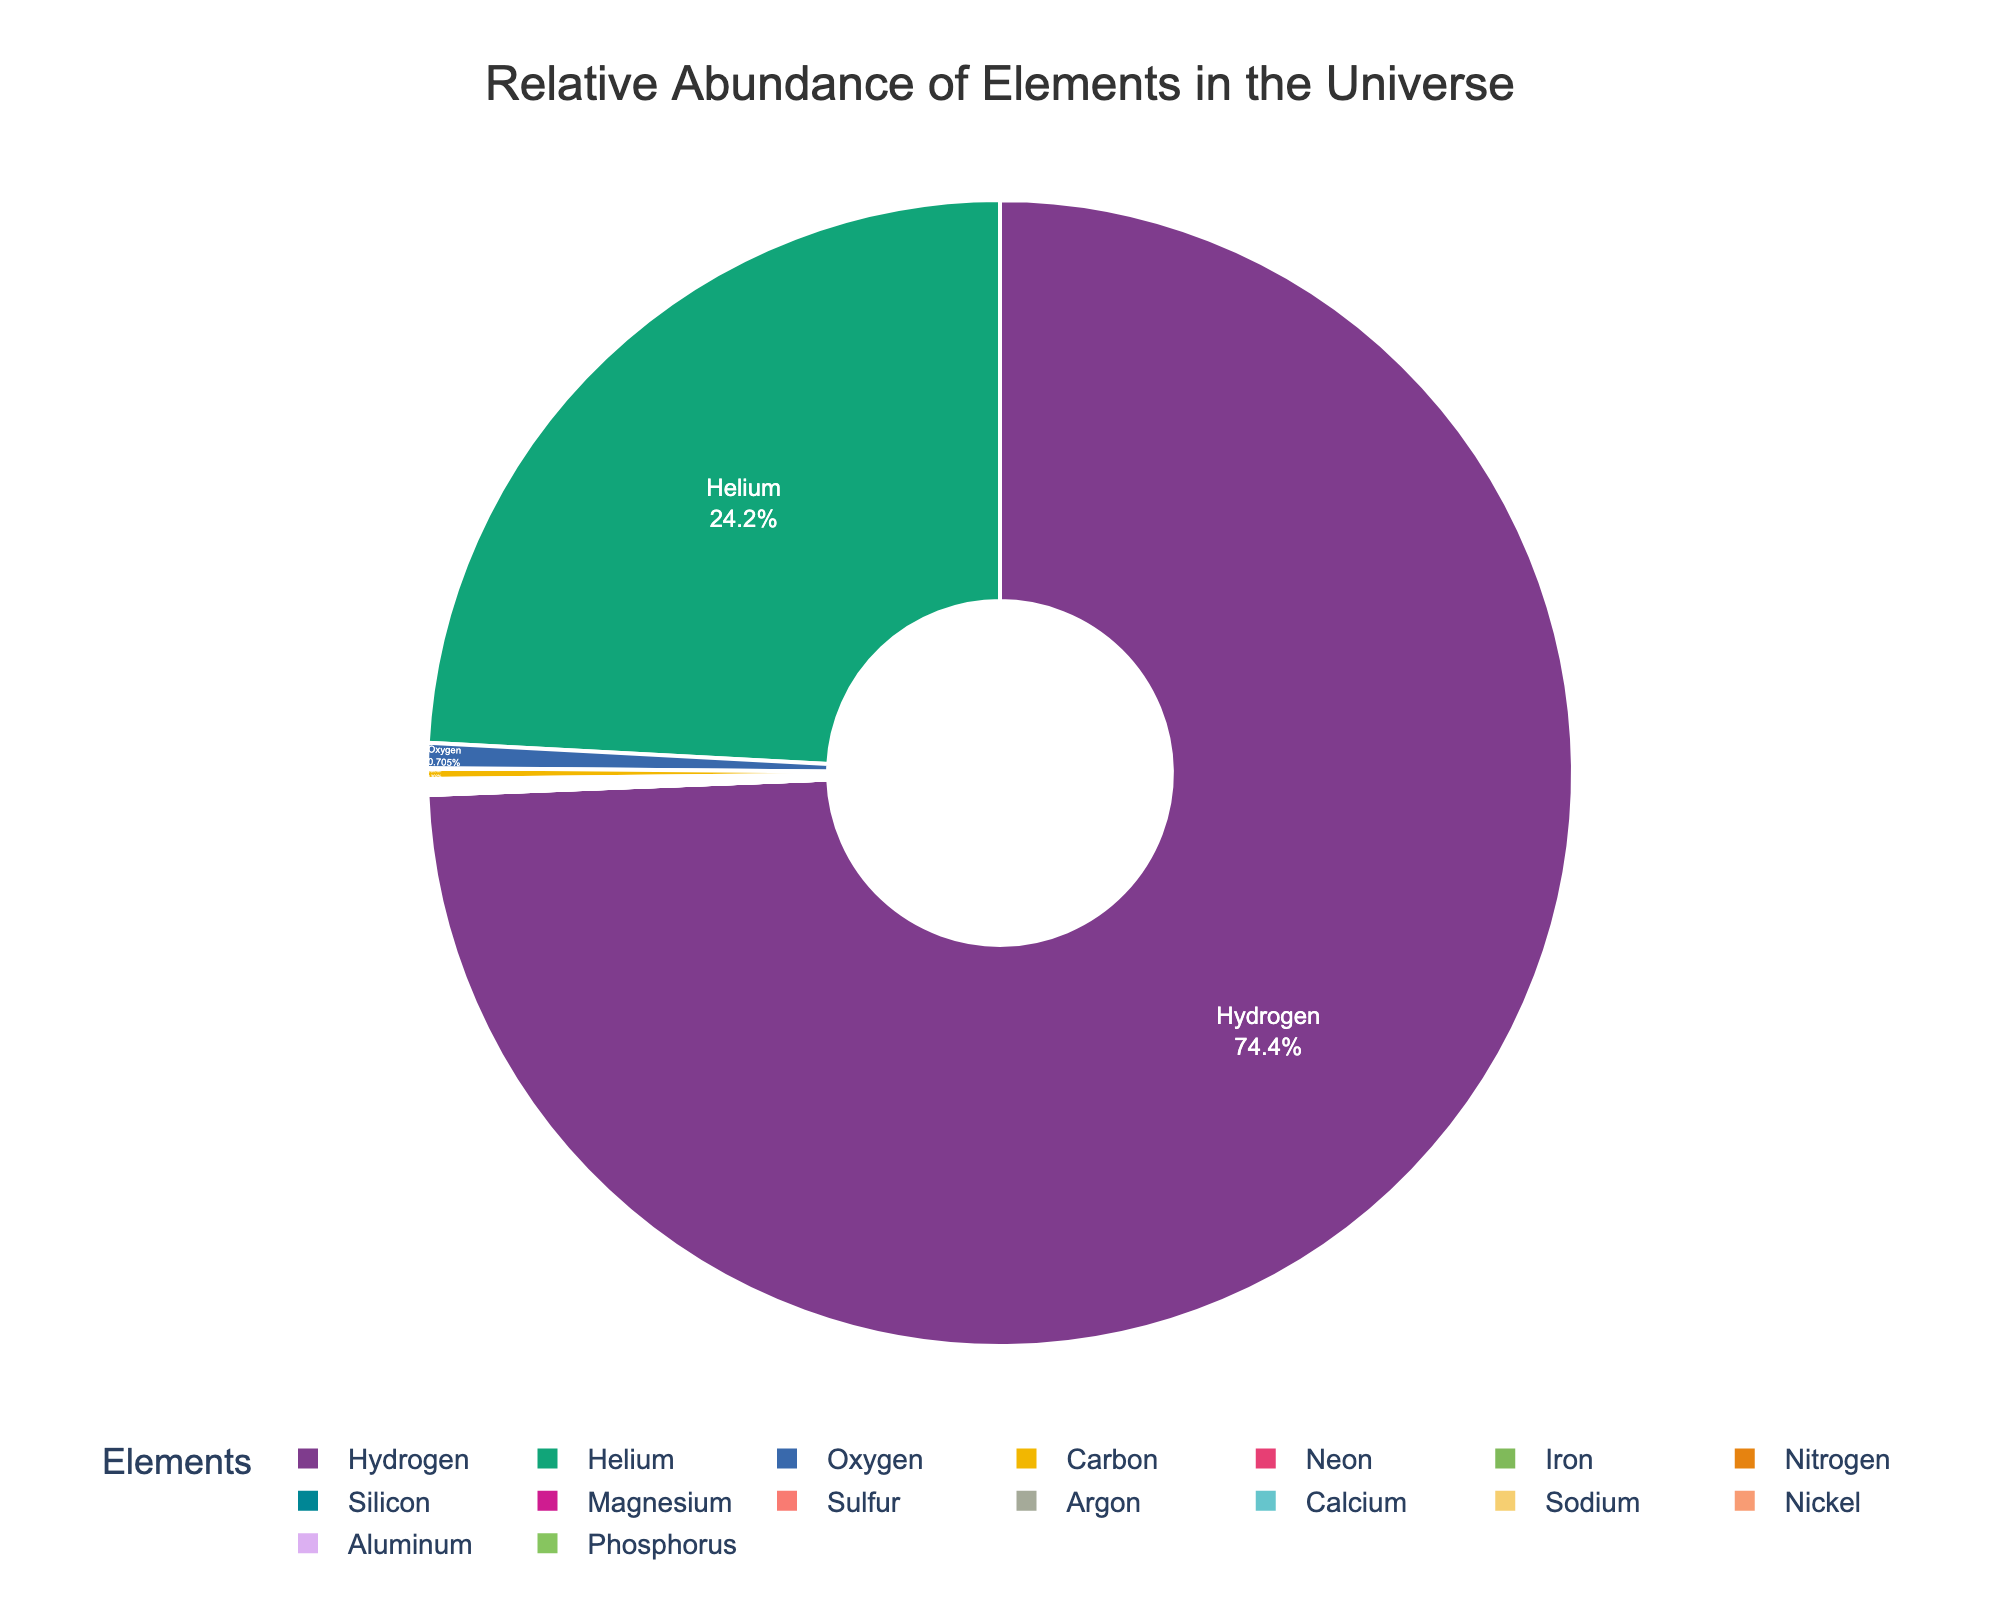What's the most abundant element shown in the pie chart? By looking at the pie chart, it's clear that the largest segment represents the most abundant element in the universe by mass. The label on this segment shows that it's Hydrogen, with 73.9%.
Answer: Hydrogen Which two elements have nearly equal relative abundances? By inspecting the sizes of the segments and their percentages, Neon, Iron, and Nitrogen all have nearly equal abundances, each at 0.1%.
Answer: Neon, Iron, and Nitrogen What is the sum of the percentages of Hydrogen and Helium? From the pie chart, Hydrogen makes up 73.9% and Helium 24.0%. Adding them together gives 73.9% + 24.0% = 97.9%.
Answer: 97.9% Which element's segment is the smallest in the pie chart and what's its percentage? The smallest segment in the chart is clearly Phosphorus, which has a label indicating its percentage as 0.001%.
Answer: Phosphorus, 0.001% Are there more elements with a relative abundance of 0.1% than elements with less than 0.1%? By counting the number of elements in each group: there are three elements with 0.1% (Neon, Iron, Nitrogen) and more than three elements with a percentage less than 0.1%.
Answer: No Compare the relative abundance of Oxygen to Carbon. How many times more abundant is Oxygen than Carbon? Oxygen has a relative abundance of 0.7%, while Carbon has 0.3%. To find how many times more abundant Oxygen is compared to Carbon: 0.7 / 0.3 ≈ 2.33.
Answer: Approximately 2.33 times How does the sum of the percentages for elements heavier than Neon compare to the percentage of Helium? First, identify elements heavier than Neon and sum their percentages: Elements heavier than Neon = Iron (0.1) + Nitrogen (0.1) + Silicon (0.05) + Magnesium (0.05) + Sulfur (0.02) + Argon (0.01) + Calcium (0.007) + Sodium (0.002) + Nickel (0.002) + Aluminum (0.002) + Phosphorus (0.001) = 0.344%. The percentage of Helium is 24.0%. 0.344% is much less than 24.0%.
Answer: Helium is much more abundant What is the combined percentage of elements with a relative abundance between 0.02% and 0.1%? The elements in the given range are Silicon (0.05), Magnesium (0.05), Sulfur (0.02). Adding them: 0.05 + 0.05 + 0.02 = 0.12%.
Answer: 0.12% 